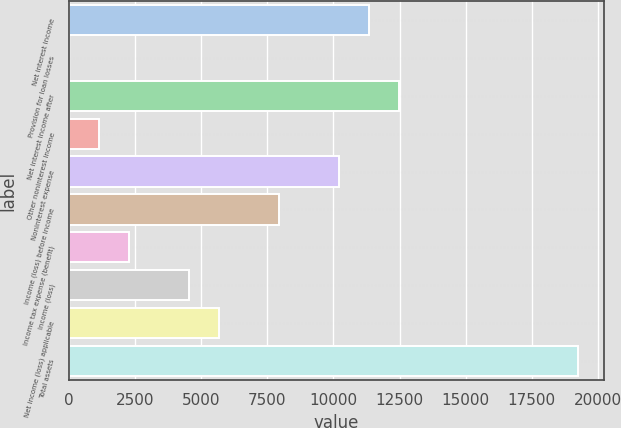<chart> <loc_0><loc_0><loc_500><loc_500><bar_chart><fcel>Net interest income<fcel>Provision for loan losses<fcel>Net interest income after<fcel>Other noninterest income<fcel>Noninterest expense<fcel>Income (loss) before income<fcel>Income tax expense (benefit)<fcel>Income (loss)<fcel>Net income (loss) applicable<fcel>Total assets<nl><fcel>11340<fcel>20.1<fcel>12472<fcel>1152.09<fcel>10208<fcel>7944.03<fcel>2284.08<fcel>4548.06<fcel>5680.05<fcel>19263.9<nl></chart> 